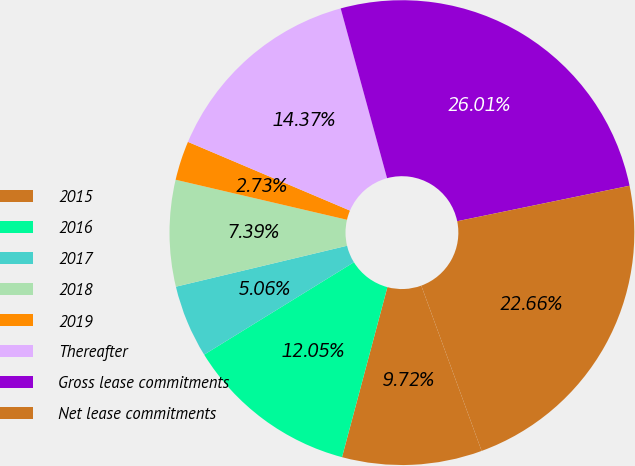<chart> <loc_0><loc_0><loc_500><loc_500><pie_chart><fcel>2015<fcel>2016<fcel>2017<fcel>2018<fcel>2019<fcel>Thereafter<fcel>Gross lease commitments<fcel>Net lease commitments<nl><fcel>9.72%<fcel>12.05%<fcel>5.06%<fcel>7.39%<fcel>2.73%<fcel>14.37%<fcel>26.01%<fcel>22.66%<nl></chart> 